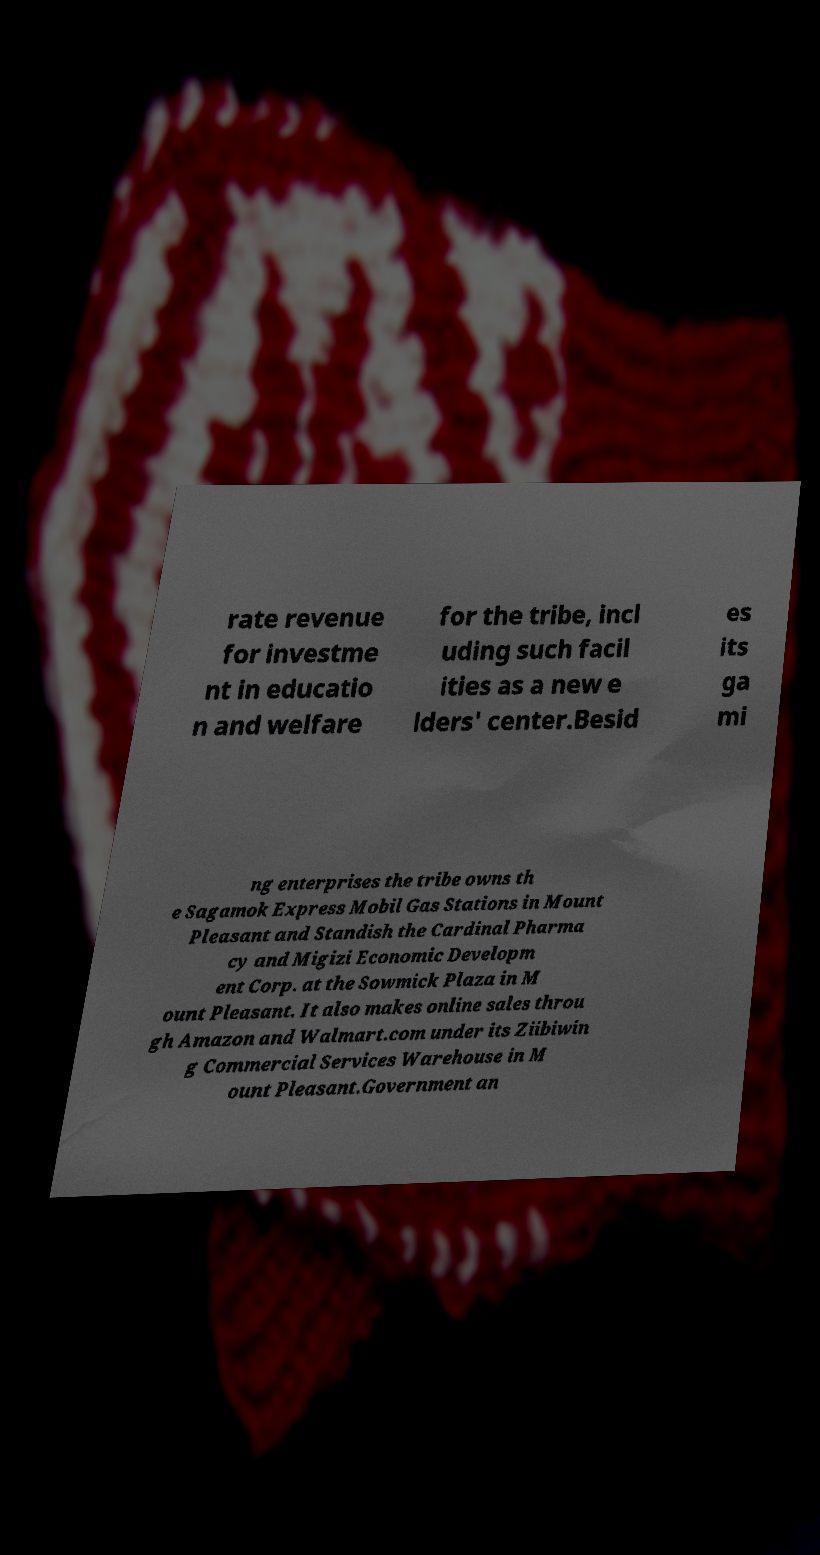What messages or text are displayed in this image? I need them in a readable, typed format. rate revenue for investme nt in educatio n and welfare for the tribe, incl uding such facil ities as a new e lders' center.Besid es its ga mi ng enterprises the tribe owns th e Sagamok Express Mobil Gas Stations in Mount Pleasant and Standish the Cardinal Pharma cy and Migizi Economic Developm ent Corp. at the Sowmick Plaza in M ount Pleasant. It also makes online sales throu gh Amazon and Walmart.com under its Ziibiwin g Commercial Services Warehouse in M ount Pleasant.Government an 